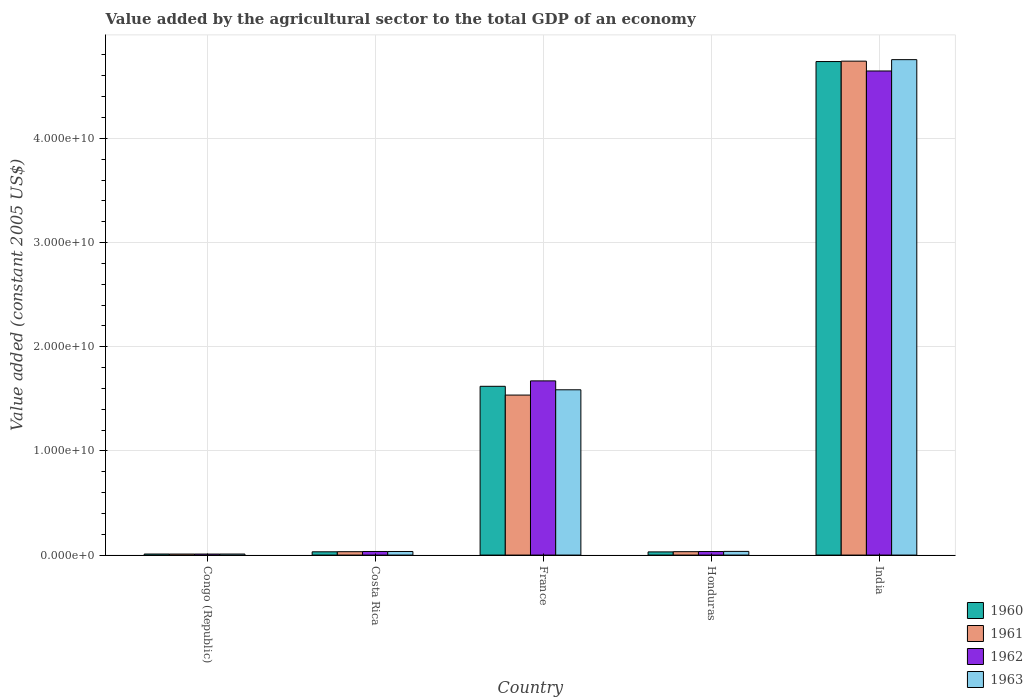How many different coloured bars are there?
Provide a succinct answer. 4. Are the number of bars per tick equal to the number of legend labels?
Your response must be concise. Yes. Are the number of bars on each tick of the X-axis equal?
Ensure brevity in your answer.  Yes. How many bars are there on the 3rd tick from the left?
Your answer should be compact. 4. How many bars are there on the 1st tick from the right?
Your answer should be compact. 4. What is the label of the 4th group of bars from the left?
Keep it short and to the point. Honduras. In how many cases, is the number of bars for a given country not equal to the number of legend labels?
Make the answer very short. 0. What is the value added by the agricultural sector in 1963 in India?
Offer a very short reply. 4.76e+1. Across all countries, what is the maximum value added by the agricultural sector in 1962?
Provide a short and direct response. 4.65e+1. Across all countries, what is the minimum value added by the agricultural sector in 1961?
Offer a terse response. 9.74e+07. In which country was the value added by the agricultural sector in 1962 maximum?
Provide a short and direct response. India. In which country was the value added by the agricultural sector in 1960 minimum?
Provide a short and direct response. Congo (Republic). What is the total value added by the agricultural sector in 1963 in the graph?
Your response must be concise. 6.42e+1. What is the difference between the value added by the agricultural sector in 1963 in Costa Rica and that in India?
Offer a very short reply. -4.72e+1. What is the difference between the value added by the agricultural sector in 1962 in Honduras and the value added by the agricultural sector in 1961 in India?
Offer a terse response. -4.71e+1. What is the average value added by the agricultural sector in 1963 per country?
Your response must be concise. 1.28e+1. What is the difference between the value added by the agricultural sector of/in 1963 and value added by the agricultural sector of/in 1962 in France?
Ensure brevity in your answer.  -8.56e+08. What is the ratio of the value added by the agricultural sector in 1963 in Congo (Republic) to that in Honduras?
Provide a succinct answer. 0.28. Is the difference between the value added by the agricultural sector in 1963 in Congo (Republic) and India greater than the difference between the value added by the agricultural sector in 1962 in Congo (Republic) and India?
Keep it short and to the point. No. What is the difference between the highest and the second highest value added by the agricultural sector in 1962?
Make the answer very short. 4.61e+1. What is the difference between the highest and the lowest value added by the agricultural sector in 1961?
Make the answer very short. 4.73e+1. Is the sum of the value added by the agricultural sector in 1960 in Congo (Republic) and Costa Rica greater than the maximum value added by the agricultural sector in 1963 across all countries?
Your answer should be very brief. No. Is it the case that in every country, the sum of the value added by the agricultural sector in 1960 and value added by the agricultural sector in 1963 is greater than the sum of value added by the agricultural sector in 1961 and value added by the agricultural sector in 1962?
Offer a terse response. No. What does the 3rd bar from the right in Honduras represents?
Give a very brief answer. 1961. Is it the case that in every country, the sum of the value added by the agricultural sector in 1960 and value added by the agricultural sector in 1963 is greater than the value added by the agricultural sector in 1962?
Give a very brief answer. Yes. Are all the bars in the graph horizontal?
Provide a succinct answer. No. How many countries are there in the graph?
Your answer should be compact. 5. What is the difference between two consecutive major ticks on the Y-axis?
Give a very brief answer. 1.00e+1. Does the graph contain any zero values?
Ensure brevity in your answer.  No. How are the legend labels stacked?
Your response must be concise. Vertical. What is the title of the graph?
Ensure brevity in your answer.  Value added by the agricultural sector to the total GDP of an economy. Does "1960" appear as one of the legend labels in the graph?
Your answer should be very brief. Yes. What is the label or title of the X-axis?
Keep it short and to the point. Country. What is the label or title of the Y-axis?
Ensure brevity in your answer.  Value added (constant 2005 US$). What is the Value added (constant 2005 US$) in 1960 in Congo (Republic)?
Ensure brevity in your answer.  1.01e+08. What is the Value added (constant 2005 US$) of 1961 in Congo (Republic)?
Keep it short and to the point. 9.74e+07. What is the Value added (constant 2005 US$) of 1962 in Congo (Republic)?
Provide a succinct answer. 9.79e+07. What is the Value added (constant 2005 US$) of 1963 in Congo (Republic)?
Your answer should be very brief. 9.86e+07. What is the Value added (constant 2005 US$) of 1960 in Costa Rica?
Your answer should be very brief. 3.13e+08. What is the Value added (constant 2005 US$) in 1961 in Costa Rica?
Offer a very short reply. 3.24e+08. What is the Value added (constant 2005 US$) in 1962 in Costa Rica?
Ensure brevity in your answer.  3.44e+08. What is the Value added (constant 2005 US$) in 1963 in Costa Rica?
Your answer should be compact. 3.43e+08. What is the Value added (constant 2005 US$) in 1960 in France?
Ensure brevity in your answer.  1.62e+1. What is the Value added (constant 2005 US$) in 1961 in France?
Provide a succinct answer. 1.54e+1. What is the Value added (constant 2005 US$) of 1962 in France?
Offer a very short reply. 1.67e+1. What is the Value added (constant 2005 US$) of 1963 in France?
Keep it short and to the point. 1.59e+1. What is the Value added (constant 2005 US$) in 1960 in Honduras?
Your answer should be compact. 3.05e+08. What is the Value added (constant 2005 US$) in 1961 in Honduras?
Your answer should be very brief. 3.25e+08. What is the Value added (constant 2005 US$) in 1962 in Honduras?
Provide a succinct answer. 3.41e+08. What is the Value added (constant 2005 US$) of 1963 in Honduras?
Ensure brevity in your answer.  3.53e+08. What is the Value added (constant 2005 US$) of 1960 in India?
Give a very brief answer. 4.74e+1. What is the Value added (constant 2005 US$) of 1961 in India?
Offer a terse response. 4.74e+1. What is the Value added (constant 2005 US$) of 1962 in India?
Make the answer very short. 4.65e+1. What is the Value added (constant 2005 US$) of 1963 in India?
Your answer should be compact. 4.76e+1. Across all countries, what is the maximum Value added (constant 2005 US$) in 1960?
Your answer should be compact. 4.74e+1. Across all countries, what is the maximum Value added (constant 2005 US$) in 1961?
Keep it short and to the point. 4.74e+1. Across all countries, what is the maximum Value added (constant 2005 US$) in 1962?
Your answer should be very brief. 4.65e+1. Across all countries, what is the maximum Value added (constant 2005 US$) in 1963?
Your response must be concise. 4.76e+1. Across all countries, what is the minimum Value added (constant 2005 US$) in 1960?
Make the answer very short. 1.01e+08. Across all countries, what is the minimum Value added (constant 2005 US$) of 1961?
Provide a short and direct response. 9.74e+07. Across all countries, what is the minimum Value added (constant 2005 US$) of 1962?
Ensure brevity in your answer.  9.79e+07. Across all countries, what is the minimum Value added (constant 2005 US$) of 1963?
Offer a very short reply. 9.86e+07. What is the total Value added (constant 2005 US$) in 1960 in the graph?
Your answer should be very brief. 6.43e+1. What is the total Value added (constant 2005 US$) of 1961 in the graph?
Offer a very short reply. 6.35e+1. What is the total Value added (constant 2005 US$) of 1962 in the graph?
Ensure brevity in your answer.  6.40e+1. What is the total Value added (constant 2005 US$) of 1963 in the graph?
Provide a succinct answer. 6.42e+1. What is the difference between the Value added (constant 2005 US$) in 1960 in Congo (Republic) and that in Costa Rica?
Your response must be concise. -2.12e+08. What is the difference between the Value added (constant 2005 US$) of 1961 in Congo (Republic) and that in Costa Rica?
Ensure brevity in your answer.  -2.27e+08. What is the difference between the Value added (constant 2005 US$) of 1962 in Congo (Republic) and that in Costa Rica?
Keep it short and to the point. -2.46e+08. What is the difference between the Value added (constant 2005 US$) in 1963 in Congo (Republic) and that in Costa Rica?
Make the answer very short. -2.45e+08. What is the difference between the Value added (constant 2005 US$) in 1960 in Congo (Republic) and that in France?
Ensure brevity in your answer.  -1.61e+1. What is the difference between the Value added (constant 2005 US$) in 1961 in Congo (Republic) and that in France?
Ensure brevity in your answer.  -1.53e+1. What is the difference between the Value added (constant 2005 US$) in 1962 in Congo (Republic) and that in France?
Offer a very short reply. -1.66e+1. What is the difference between the Value added (constant 2005 US$) of 1963 in Congo (Republic) and that in France?
Your answer should be compact. -1.58e+1. What is the difference between the Value added (constant 2005 US$) of 1960 in Congo (Republic) and that in Honduras?
Offer a very short reply. -2.04e+08. What is the difference between the Value added (constant 2005 US$) in 1961 in Congo (Republic) and that in Honduras?
Ensure brevity in your answer.  -2.28e+08. What is the difference between the Value added (constant 2005 US$) of 1962 in Congo (Republic) and that in Honduras?
Ensure brevity in your answer.  -2.43e+08. What is the difference between the Value added (constant 2005 US$) in 1963 in Congo (Republic) and that in Honduras?
Offer a terse response. -2.55e+08. What is the difference between the Value added (constant 2005 US$) in 1960 in Congo (Republic) and that in India?
Keep it short and to the point. -4.73e+1. What is the difference between the Value added (constant 2005 US$) of 1961 in Congo (Republic) and that in India?
Keep it short and to the point. -4.73e+1. What is the difference between the Value added (constant 2005 US$) in 1962 in Congo (Republic) and that in India?
Keep it short and to the point. -4.64e+1. What is the difference between the Value added (constant 2005 US$) in 1963 in Congo (Republic) and that in India?
Give a very brief answer. -4.75e+1. What is the difference between the Value added (constant 2005 US$) in 1960 in Costa Rica and that in France?
Your answer should be compact. -1.59e+1. What is the difference between the Value added (constant 2005 US$) of 1961 in Costa Rica and that in France?
Provide a short and direct response. -1.50e+1. What is the difference between the Value added (constant 2005 US$) of 1962 in Costa Rica and that in France?
Keep it short and to the point. -1.64e+1. What is the difference between the Value added (constant 2005 US$) of 1963 in Costa Rica and that in France?
Your answer should be very brief. -1.55e+1. What is the difference between the Value added (constant 2005 US$) in 1960 in Costa Rica and that in Honduras?
Your response must be concise. 7.61e+06. What is the difference between the Value added (constant 2005 US$) of 1961 in Costa Rica and that in Honduras?
Keep it short and to the point. -8.14e+05. What is the difference between the Value added (constant 2005 US$) in 1962 in Costa Rica and that in Honduras?
Your response must be concise. 3.61e+06. What is the difference between the Value added (constant 2005 US$) of 1963 in Costa Rica and that in Honduras?
Provide a short and direct response. -9.78e+06. What is the difference between the Value added (constant 2005 US$) in 1960 in Costa Rica and that in India?
Your answer should be compact. -4.71e+1. What is the difference between the Value added (constant 2005 US$) of 1961 in Costa Rica and that in India?
Give a very brief answer. -4.71e+1. What is the difference between the Value added (constant 2005 US$) of 1962 in Costa Rica and that in India?
Provide a short and direct response. -4.61e+1. What is the difference between the Value added (constant 2005 US$) in 1963 in Costa Rica and that in India?
Ensure brevity in your answer.  -4.72e+1. What is the difference between the Value added (constant 2005 US$) of 1960 in France and that in Honduras?
Provide a short and direct response. 1.59e+1. What is the difference between the Value added (constant 2005 US$) in 1961 in France and that in Honduras?
Give a very brief answer. 1.50e+1. What is the difference between the Value added (constant 2005 US$) in 1962 in France and that in Honduras?
Provide a short and direct response. 1.64e+1. What is the difference between the Value added (constant 2005 US$) in 1963 in France and that in Honduras?
Your response must be concise. 1.55e+1. What is the difference between the Value added (constant 2005 US$) of 1960 in France and that in India?
Offer a terse response. -3.12e+1. What is the difference between the Value added (constant 2005 US$) of 1961 in France and that in India?
Offer a very short reply. -3.21e+1. What is the difference between the Value added (constant 2005 US$) in 1962 in France and that in India?
Make the answer very short. -2.97e+1. What is the difference between the Value added (constant 2005 US$) in 1963 in France and that in India?
Your answer should be very brief. -3.17e+1. What is the difference between the Value added (constant 2005 US$) of 1960 in Honduras and that in India?
Provide a succinct answer. -4.71e+1. What is the difference between the Value added (constant 2005 US$) in 1961 in Honduras and that in India?
Keep it short and to the point. -4.71e+1. What is the difference between the Value added (constant 2005 US$) in 1962 in Honduras and that in India?
Give a very brief answer. -4.61e+1. What is the difference between the Value added (constant 2005 US$) in 1963 in Honduras and that in India?
Your answer should be compact. -4.72e+1. What is the difference between the Value added (constant 2005 US$) of 1960 in Congo (Republic) and the Value added (constant 2005 US$) of 1961 in Costa Rica?
Your answer should be compact. -2.24e+08. What is the difference between the Value added (constant 2005 US$) of 1960 in Congo (Republic) and the Value added (constant 2005 US$) of 1962 in Costa Rica?
Offer a very short reply. -2.43e+08. What is the difference between the Value added (constant 2005 US$) in 1960 in Congo (Republic) and the Value added (constant 2005 US$) in 1963 in Costa Rica?
Offer a very short reply. -2.42e+08. What is the difference between the Value added (constant 2005 US$) in 1961 in Congo (Republic) and the Value added (constant 2005 US$) in 1962 in Costa Rica?
Offer a terse response. -2.47e+08. What is the difference between the Value added (constant 2005 US$) in 1961 in Congo (Republic) and the Value added (constant 2005 US$) in 1963 in Costa Rica?
Give a very brief answer. -2.46e+08. What is the difference between the Value added (constant 2005 US$) of 1962 in Congo (Republic) and the Value added (constant 2005 US$) of 1963 in Costa Rica?
Offer a terse response. -2.45e+08. What is the difference between the Value added (constant 2005 US$) in 1960 in Congo (Republic) and the Value added (constant 2005 US$) in 1961 in France?
Ensure brevity in your answer.  -1.53e+1. What is the difference between the Value added (constant 2005 US$) of 1960 in Congo (Republic) and the Value added (constant 2005 US$) of 1962 in France?
Your response must be concise. -1.66e+1. What is the difference between the Value added (constant 2005 US$) in 1960 in Congo (Republic) and the Value added (constant 2005 US$) in 1963 in France?
Ensure brevity in your answer.  -1.58e+1. What is the difference between the Value added (constant 2005 US$) of 1961 in Congo (Republic) and the Value added (constant 2005 US$) of 1962 in France?
Give a very brief answer. -1.66e+1. What is the difference between the Value added (constant 2005 US$) in 1961 in Congo (Republic) and the Value added (constant 2005 US$) in 1963 in France?
Your answer should be compact. -1.58e+1. What is the difference between the Value added (constant 2005 US$) in 1962 in Congo (Republic) and the Value added (constant 2005 US$) in 1963 in France?
Give a very brief answer. -1.58e+1. What is the difference between the Value added (constant 2005 US$) of 1960 in Congo (Republic) and the Value added (constant 2005 US$) of 1961 in Honduras?
Offer a very short reply. -2.24e+08. What is the difference between the Value added (constant 2005 US$) in 1960 in Congo (Republic) and the Value added (constant 2005 US$) in 1962 in Honduras?
Make the answer very short. -2.40e+08. What is the difference between the Value added (constant 2005 US$) in 1960 in Congo (Republic) and the Value added (constant 2005 US$) in 1963 in Honduras?
Give a very brief answer. -2.52e+08. What is the difference between the Value added (constant 2005 US$) of 1961 in Congo (Republic) and the Value added (constant 2005 US$) of 1962 in Honduras?
Offer a very short reply. -2.43e+08. What is the difference between the Value added (constant 2005 US$) of 1961 in Congo (Republic) and the Value added (constant 2005 US$) of 1963 in Honduras?
Ensure brevity in your answer.  -2.56e+08. What is the difference between the Value added (constant 2005 US$) in 1962 in Congo (Republic) and the Value added (constant 2005 US$) in 1963 in Honduras?
Give a very brief answer. -2.55e+08. What is the difference between the Value added (constant 2005 US$) of 1960 in Congo (Republic) and the Value added (constant 2005 US$) of 1961 in India?
Offer a very short reply. -4.73e+1. What is the difference between the Value added (constant 2005 US$) in 1960 in Congo (Republic) and the Value added (constant 2005 US$) in 1962 in India?
Give a very brief answer. -4.64e+1. What is the difference between the Value added (constant 2005 US$) in 1960 in Congo (Republic) and the Value added (constant 2005 US$) in 1963 in India?
Make the answer very short. -4.75e+1. What is the difference between the Value added (constant 2005 US$) in 1961 in Congo (Republic) and the Value added (constant 2005 US$) in 1962 in India?
Ensure brevity in your answer.  -4.64e+1. What is the difference between the Value added (constant 2005 US$) in 1961 in Congo (Republic) and the Value added (constant 2005 US$) in 1963 in India?
Offer a terse response. -4.75e+1. What is the difference between the Value added (constant 2005 US$) in 1962 in Congo (Republic) and the Value added (constant 2005 US$) in 1963 in India?
Offer a very short reply. -4.75e+1. What is the difference between the Value added (constant 2005 US$) of 1960 in Costa Rica and the Value added (constant 2005 US$) of 1961 in France?
Offer a very short reply. -1.50e+1. What is the difference between the Value added (constant 2005 US$) of 1960 in Costa Rica and the Value added (constant 2005 US$) of 1962 in France?
Ensure brevity in your answer.  -1.64e+1. What is the difference between the Value added (constant 2005 US$) in 1960 in Costa Rica and the Value added (constant 2005 US$) in 1963 in France?
Give a very brief answer. -1.56e+1. What is the difference between the Value added (constant 2005 US$) in 1961 in Costa Rica and the Value added (constant 2005 US$) in 1962 in France?
Give a very brief answer. -1.64e+1. What is the difference between the Value added (constant 2005 US$) of 1961 in Costa Rica and the Value added (constant 2005 US$) of 1963 in France?
Make the answer very short. -1.55e+1. What is the difference between the Value added (constant 2005 US$) in 1962 in Costa Rica and the Value added (constant 2005 US$) in 1963 in France?
Make the answer very short. -1.55e+1. What is the difference between the Value added (constant 2005 US$) of 1960 in Costa Rica and the Value added (constant 2005 US$) of 1961 in Honduras?
Keep it short and to the point. -1.23e+07. What is the difference between the Value added (constant 2005 US$) in 1960 in Costa Rica and the Value added (constant 2005 US$) in 1962 in Honduras?
Offer a terse response. -2.78e+07. What is the difference between the Value added (constant 2005 US$) in 1960 in Costa Rica and the Value added (constant 2005 US$) in 1963 in Honduras?
Your answer should be very brief. -4.02e+07. What is the difference between the Value added (constant 2005 US$) of 1961 in Costa Rica and the Value added (constant 2005 US$) of 1962 in Honduras?
Give a very brief answer. -1.63e+07. What is the difference between the Value added (constant 2005 US$) in 1961 in Costa Rica and the Value added (constant 2005 US$) in 1963 in Honduras?
Your answer should be compact. -2.87e+07. What is the difference between the Value added (constant 2005 US$) of 1962 in Costa Rica and the Value added (constant 2005 US$) of 1963 in Honduras?
Your answer should be very brief. -8.78e+06. What is the difference between the Value added (constant 2005 US$) of 1960 in Costa Rica and the Value added (constant 2005 US$) of 1961 in India?
Your answer should be compact. -4.71e+1. What is the difference between the Value added (constant 2005 US$) in 1960 in Costa Rica and the Value added (constant 2005 US$) in 1962 in India?
Ensure brevity in your answer.  -4.62e+1. What is the difference between the Value added (constant 2005 US$) of 1960 in Costa Rica and the Value added (constant 2005 US$) of 1963 in India?
Give a very brief answer. -4.72e+1. What is the difference between the Value added (constant 2005 US$) of 1961 in Costa Rica and the Value added (constant 2005 US$) of 1962 in India?
Make the answer very short. -4.61e+1. What is the difference between the Value added (constant 2005 US$) of 1961 in Costa Rica and the Value added (constant 2005 US$) of 1963 in India?
Your response must be concise. -4.72e+1. What is the difference between the Value added (constant 2005 US$) of 1962 in Costa Rica and the Value added (constant 2005 US$) of 1963 in India?
Ensure brevity in your answer.  -4.72e+1. What is the difference between the Value added (constant 2005 US$) of 1960 in France and the Value added (constant 2005 US$) of 1961 in Honduras?
Make the answer very short. 1.59e+1. What is the difference between the Value added (constant 2005 US$) in 1960 in France and the Value added (constant 2005 US$) in 1962 in Honduras?
Offer a very short reply. 1.59e+1. What is the difference between the Value added (constant 2005 US$) in 1960 in France and the Value added (constant 2005 US$) in 1963 in Honduras?
Your answer should be very brief. 1.58e+1. What is the difference between the Value added (constant 2005 US$) of 1961 in France and the Value added (constant 2005 US$) of 1962 in Honduras?
Provide a succinct answer. 1.50e+1. What is the difference between the Value added (constant 2005 US$) in 1961 in France and the Value added (constant 2005 US$) in 1963 in Honduras?
Your response must be concise. 1.50e+1. What is the difference between the Value added (constant 2005 US$) in 1962 in France and the Value added (constant 2005 US$) in 1963 in Honduras?
Offer a very short reply. 1.64e+1. What is the difference between the Value added (constant 2005 US$) in 1960 in France and the Value added (constant 2005 US$) in 1961 in India?
Your answer should be compact. -3.12e+1. What is the difference between the Value added (constant 2005 US$) of 1960 in France and the Value added (constant 2005 US$) of 1962 in India?
Offer a terse response. -3.03e+1. What is the difference between the Value added (constant 2005 US$) in 1960 in France and the Value added (constant 2005 US$) in 1963 in India?
Provide a succinct answer. -3.14e+1. What is the difference between the Value added (constant 2005 US$) of 1961 in France and the Value added (constant 2005 US$) of 1962 in India?
Keep it short and to the point. -3.11e+1. What is the difference between the Value added (constant 2005 US$) of 1961 in France and the Value added (constant 2005 US$) of 1963 in India?
Offer a terse response. -3.22e+1. What is the difference between the Value added (constant 2005 US$) in 1962 in France and the Value added (constant 2005 US$) in 1963 in India?
Give a very brief answer. -3.08e+1. What is the difference between the Value added (constant 2005 US$) of 1960 in Honduras and the Value added (constant 2005 US$) of 1961 in India?
Ensure brevity in your answer.  -4.71e+1. What is the difference between the Value added (constant 2005 US$) of 1960 in Honduras and the Value added (constant 2005 US$) of 1962 in India?
Your answer should be compact. -4.62e+1. What is the difference between the Value added (constant 2005 US$) in 1960 in Honduras and the Value added (constant 2005 US$) in 1963 in India?
Your response must be concise. -4.72e+1. What is the difference between the Value added (constant 2005 US$) in 1961 in Honduras and the Value added (constant 2005 US$) in 1962 in India?
Your answer should be very brief. -4.61e+1. What is the difference between the Value added (constant 2005 US$) of 1961 in Honduras and the Value added (constant 2005 US$) of 1963 in India?
Provide a succinct answer. -4.72e+1. What is the difference between the Value added (constant 2005 US$) of 1962 in Honduras and the Value added (constant 2005 US$) of 1963 in India?
Keep it short and to the point. -4.72e+1. What is the average Value added (constant 2005 US$) of 1960 per country?
Offer a terse response. 1.29e+1. What is the average Value added (constant 2005 US$) in 1961 per country?
Keep it short and to the point. 1.27e+1. What is the average Value added (constant 2005 US$) in 1962 per country?
Provide a succinct answer. 1.28e+1. What is the average Value added (constant 2005 US$) of 1963 per country?
Make the answer very short. 1.28e+1. What is the difference between the Value added (constant 2005 US$) in 1960 and Value added (constant 2005 US$) in 1961 in Congo (Republic)?
Give a very brief answer. 3.61e+06. What is the difference between the Value added (constant 2005 US$) of 1960 and Value added (constant 2005 US$) of 1962 in Congo (Republic)?
Keep it short and to the point. 3.02e+06. What is the difference between the Value added (constant 2005 US$) in 1960 and Value added (constant 2005 US$) in 1963 in Congo (Republic)?
Your response must be concise. 2.34e+06. What is the difference between the Value added (constant 2005 US$) of 1961 and Value added (constant 2005 US$) of 1962 in Congo (Republic)?
Provide a succinct answer. -5.86e+05. What is the difference between the Value added (constant 2005 US$) of 1961 and Value added (constant 2005 US$) of 1963 in Congo (Republic)?
Keep it short and to the point. -1.27e+06. What is the difference between the Value added (constant 2005 US$) of 1962 and Value added (constant 2005 US$) of 1963 in Congo (Republic)?
Your answer should be compact. -6.85e+05. What is the difference between the Value added (constant 2005 US$) of 1960 and Value added (constant 2005 US$) of 1961 in Costa Rica?
Offer a very short reply. -1.15e+07. What is the difference between the Value added (constant 2005 US$) in 1960 and Value added (constant 2005 US$) in 1962 in Costa Rica?
Provide a succinct answer. -3.14e+07. What is the difference between the Value added (constant 2005 US$) in 1960 and Value added (constant 2005 US$) in 1963 in Costa Rica?
Offer a terse response. -3.04e+07. What is the difference between the Value added (constant 2005 US$) in 1961 and Value added (constant 2005 US$) in 1962 in Costa Rica?
Ensure brevity in your answer.  -1.99e+07. What is the difference between the Value added (constant 2005 US$) of 1961 and Value added (constant 2005 US$) of 1963 in Costa Rica?
Offer a terse response. -1.89e+07. What is the difference between the Value added (constant 2005 US$) of 1962 and Value added (constant 2005 US$) of 1963 in Costa Rica?
Give a very brief answer. 1.00e+06. What is the difference between the Value added (constant 2005 US$) of 1960 and Value added (constant 2005 US$) of 1961 in France?
Offer a very short reply. 8.42e+08. What is the difference between the Value added (constant 2005 US$) of 1960 and Value added (constant 2005 US$) of 1962 in France?
Your answer should be very brief. -5.20e+08. What is the difference between the Value added (constant 2005 US$) in 1960 and Value added (constant 2005 US$) in 1963 in France?
Your answer should be compact. 3.35e+08. What is the difference between the Value added (constant 2005 US$) in 1961 and Value added (constant 2005 US$) in 1962 in France?
Offer a terse response. -1.36e+09. What is the difference between the Value added (constant 2005 US$) in 1961 and Value added (constant 2005 US$) in 1963 in France?
Offer a terse response. -5.07e+08. What is the difference between the Value added (constant 2005 US$) of 1962 and Value added (constant 2005 US$) of 1963 in France?
Offer a terse response. 8.56e+08. What is the difference between the Value added (constant 2005 US$) of 1960 and Value added (constant 2005 US$) of 1961 in Honduras?
Give a very brief answer. -1.99e+07. What is the difference between the Value added (constant 2005 US$) in 1960 and Value added (constant 2005 US$) in 1962 in Honduras?
Give a very brief answer. -3.54e+07. What is the difference between the Value added (constant 2005 US$) in 1960 and Value added (constant 2005 US$) in 1963 in Honduras?
Your response must be concise. -4.78e+07. What is the difference between the Value added (constant 2005 US$) in 1961 and Value added (constant 2005 US$) in 1962 in Honduras?
Offer a terse response. -1.55e+07. What is the difference between the Value added (constant 2005 US$) in 1961 and Value added (constant 2005 US$) in 1963 in Honduras?
Provide a short and direct response. -2.79e+07. What is the difference between the Value added (constant 2005 US$) in 1962 and Value added (constant 2005 US$) in 1963 in Honduras?
Ensure brevity in your answer.  -1.24e+07. What is the difference between the Value added (constant 2005 US$) of 1960 and Value added (constant 2005 US$) of 1961 in India?
Provide a succinct answer. -3.99e+07. What is the difference between the Value added (constant 2005 US$) in 1960 and Value added (constant 2005 US$) in 1962 in India?
Provide a succinct answer. 9.03e+08. What is the difference between the Value added (constant 2005 US$) of 1960 and Value added (constant 2005 US$) of 1963 in India?
Provide a short and direct response. -1.84e+08. What is the difference between the Value added (constant 2005 US$) of 1961 and Value added (constant 2005 US$) of 1962 in India?
Offer a very short reply. 9.43e+08. What is the difference between the Value added (constant 2005 US$) of 1961 and Value added (constant 2005 US$) of 1963 in India?
Give a very brief answer. -1.44e+08. What is the difference between the Value added (constant 2005 US$) in 1962 and Value added (constant 2005 US$) in 1963 in India?
Your answer should be very brief. -1.09e+09. What is the ratio of the Value added (constant 2005 US$) in 1960 in Congo (Republic) to that in Costa Rica?
Provide a short and direct response. 0.32. What is the ratio of the Value added (constant 2005 US$) in 1962 in Congo (Republic) to that in Costa Rica?
Offer a terse response. 0.28. What is the ratio of the Value added (constant 2005 US$) in 1963 in Congo (Republic) to that in Costa Rica?
Offer a terse response. 0.29. What is the ratio of the Value added (constant 2005 US$) in 1960 in Congo (Republic) to that in France?
Provide a succinct answer. 0.01. What is the ratio of the Value added (constant 2005 US$) in 1961 in Congo (Republic) to that in France?
Your response must be concise. 0.01. What is the ratio of the Value added (constant 2005 US$) of 1962 in Congo (Republic) to that in France?
Give a very brief answer. 0.01. What is the ratio of the Value added (constant 2005 US$) in 1963 in Congo (Republic) to that in France?
Offer a very short reply. 0.01. What is the ratio of the Value added (constant 2005 US$) of 1960 in Congo (Republic) to that in Honduras?
Provide a short and direct response. 0.33. What is the ratio of the Value added (constant 2005 US$) of 1961 in Congo (Republic) to that in Honduras?
Your response must be concise. 0.3. What is the ratio of the Value added (constant 2005 US$) of 1962 in Congo (Republic) to that in Honduras?
Give a very brief answer. 0.29. What is the ratio of the Value added (constant 2005 US$) in 1963 in Congo (Republic) to that in Honduras?
Your answer should be compact. 0.28. What is the ratio of the Value added (constant 2005 US$) of 1960 in Congo (Republic) to that in India?
Your response must be concise. 0. What is the ratio of the Value added (constant 2005 US$) of 1961 in Congo (Republic) to that in India?
Keep it short and to the point. 0. What is the ratio of the Value added (constant 2005 US$) in 1962 in Congo (Republic) to that in India?
Provide a short and direct response. 0. What is the ratio of the Value added (constant 2005 US$) of 1963 in Congo (Republic) to that in India?
Provide a short and direct response. 0. What is the ratio of the Value added (constant 2005 US$) of 1960 in Costa Rica to that in France?
Keep it short and to the point. 0.02. What is the ratio of the Value added (constant 2005 US$) in 1961 in Costa Rica to that in France?
Provide a succinct answer. 0.02. What is the ratio of the Value added (constant 2005 US$) in 1962 in Costa Rica to that in France?
Provide a succinct answer. 0.02. What is the ratio of the Value added (constant 2005 US$) in 1963 in Costa Rica to that in France?
Offer a very short reply. 0.02. What is the ratio of the Value added (constant 2005 US$) of 1960 in Costa Rica to that in Honduras?
Provide a short and direct response. 1.02. What is the ratio of the Value added (constant 2005 US$) in 1962 in Costa Rica to that in Honduras?
Your response must be concise. 1.01. What is the ratio of the Value added (constant 2005 US$) of 1963 in Costa Rica to that in Honduras?
Offer a very short reply. 0.97. What is the ratio of the Value added (constant 2005 US$) in 1960 in Costa Rica to that in India?
Your response must be concise. 0.01. What is the ratio of the Value added (constant 2005 US$) of 1961 in Costa Rica to that in India?
Give a very brief answer. 0.01. What is the ratio of the Value added (constant 2005 US$) of 1962 in Costa Rica to that in India?
Offer a terse response. 0.01. What is the ratio of the Value added (constant 2005 US$) in 1963 in Costa Rica to that in India?
Offer a terse response. 0.01. What is the ratio of the Value added (constant 2005 US$) in 1960 in France to that in Honduras?
Ensure brevity in your answer.  53.05. What is the ratio of the Value added (constant 2005 US$) of 1961 in France to that in Honduras?
Provide a short and direct response. 47.21. What is the ratio of the Value added (constant 2005 US$) of 1962 in France to that in Honduras?
Your answer should be compact. 49.07. What is the ratio of the Value added (constant 2005 US$) in 1963 in France to that in Honduras?
Your response must be concise. 44.92. What is the ratio of the Value added (constant 2005 US$) in 1960 in France to that in India?
Make the answer very short. 0.34. What is the ratio of the Value added (constant 2005 US$) in 1961 in France to that in India?
Give a very brief answer. 0.32. What is the ratio of the Value added (constant 2005 US$) in 1962 in France to that in India?
Your answer should be very brief. 0.36. What is the ratio of the Value added (constant 2005 US$) of 1963 in France to that in India?
Make the answer very short. 0.33. What is the ratio of the Value added (constant 2005 US$) in 1960 in Honduras to that in India?
Your response must be concise. 0.01. What is the ratio of the Value added (constant 2005 US$) in 1961 in Honduras to that in India?
Your answer should be very brief. 0.01. What is the ratio of the Value added (constant 2005 US$) of 1962 in Honduras to that in India?
Make the answer very short. 0.01. What is the ratio of the Value added (constant 2005 US$) of 1963 in Honduras to that in India?
Your answer should be very brief. 0.01. What is the difference between the highest and the second highest Value added (constant 2005 US$) in 1960?
Keep it short and to the point. 3.12e+1. What is the difference between the highest and the second highest Value added (constant 2005 US$) of 1961?
Provide a short and direct response. 3.21e+1. What is the difference between the highest and the second highest Value added (constant 2005 US$) in 1962?
Provide a short and direct response. 2.97e+1. What is the difference between the highest and the second highest Value added (constant 2005 US$) in 1963?
Keep it short and to the point. 3.17e+1. What is the difference between the highest and the lowest Value added (constant 2005 US$) of 1960?
Your response must be concise. 4.73e+1. What is the difference between the highest and the lowest Value added (constant 2005 US$) of 1961?
Provide a short and direct response. 4.73e+1. What is the difference between the highest and the lowest Value added (constant 2005 US$) in 1962?
Your answer should be compact. 4.64e+1. What is the difference between the highest and the lowest Value added (constant 2005 US$) in 1963?
Keep it short and to the point. 4.75e+1. 